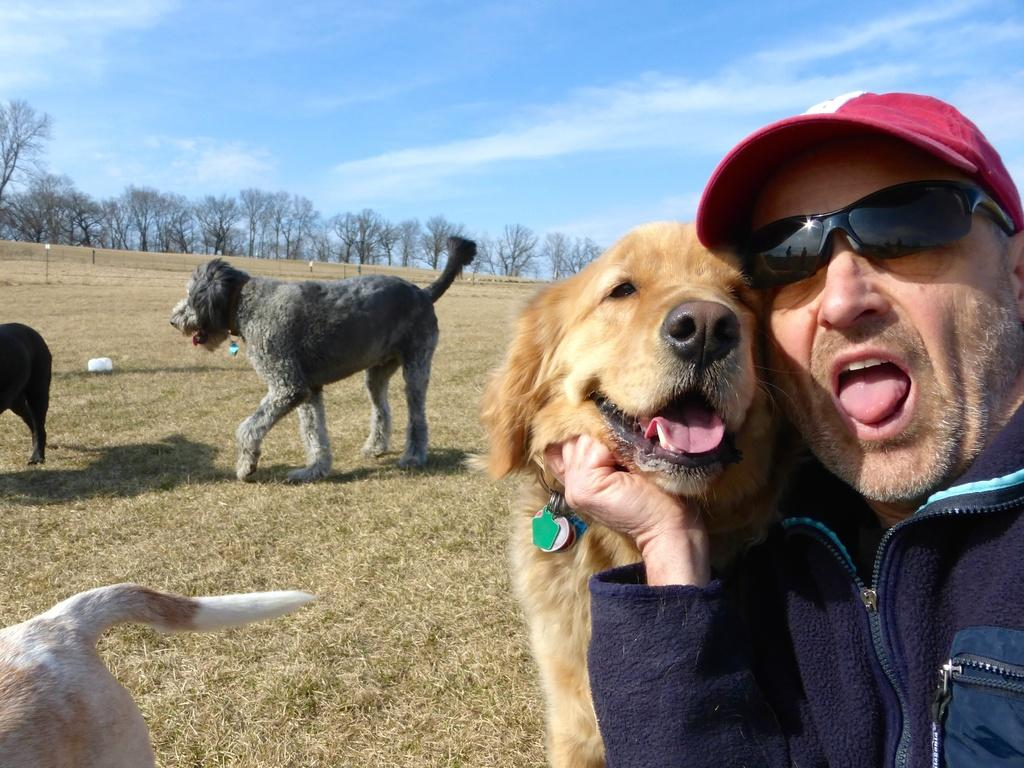Who or what is on the right side of the image? There is a person on the right side of the image. What animal is with the person? There is a dog with the person. Are there any other dogs in the image? Yes, there are more dogs behind the person and the first dog. What can be seen in the distance in the image? There are trees visible in the background of the image. What type of music is the person playing on their wrist in the image? There is no music or wrist instrument present in the image. 